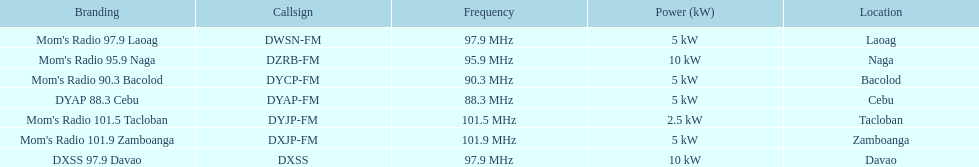What is the energy capacity in kw for each group? 5 kW, 10 kW, 5 kW, 5 kW, 2.5 kW, 5 kW, 10 kW. Which has the smallest? 2.5 kW. Which station possesses this level of energy? Mom's Radio 101.5 Tacloban. 